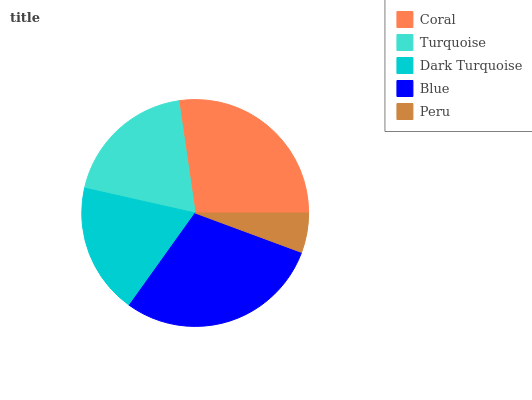Is Peru the minimum?
Answer yes or no. Yes. Is Blue the maximum?
Answer yes or no. Yes. Is Turquoise the minimum?
Answer yes or no. No. Is Turquoise the maximum?
Answer yes or no. No. Is Coral greater than Turquoise?
Answer yes or no. Yes. Is Turquoise less than Coral?
Answer yes or no. Yes. Is Turquoise greater than Coral?
Answer yes or no. No. Is Coral less than Turquoise?
Answer yes or no. No. Is Turquoise the high median?
Answer yes or no. Yes. Is Turquoise the low median?
Answer yes or no. Yes. Is Peru the high median?
Answer yes or no. No. Is Coral the low median?
Answer yes or no. No. 